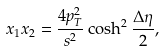Convert formula to latex. <formula><loc_0><loc_0><loc_500><loc_500>x _ { 1 } x _ { 2 } = \frac { 4 p _ { T } ^ { 2 } } { s ^ { 2 } } \cosh ^ { 2 } \frac { \Delta \eta } { 2 } ,</formula> 